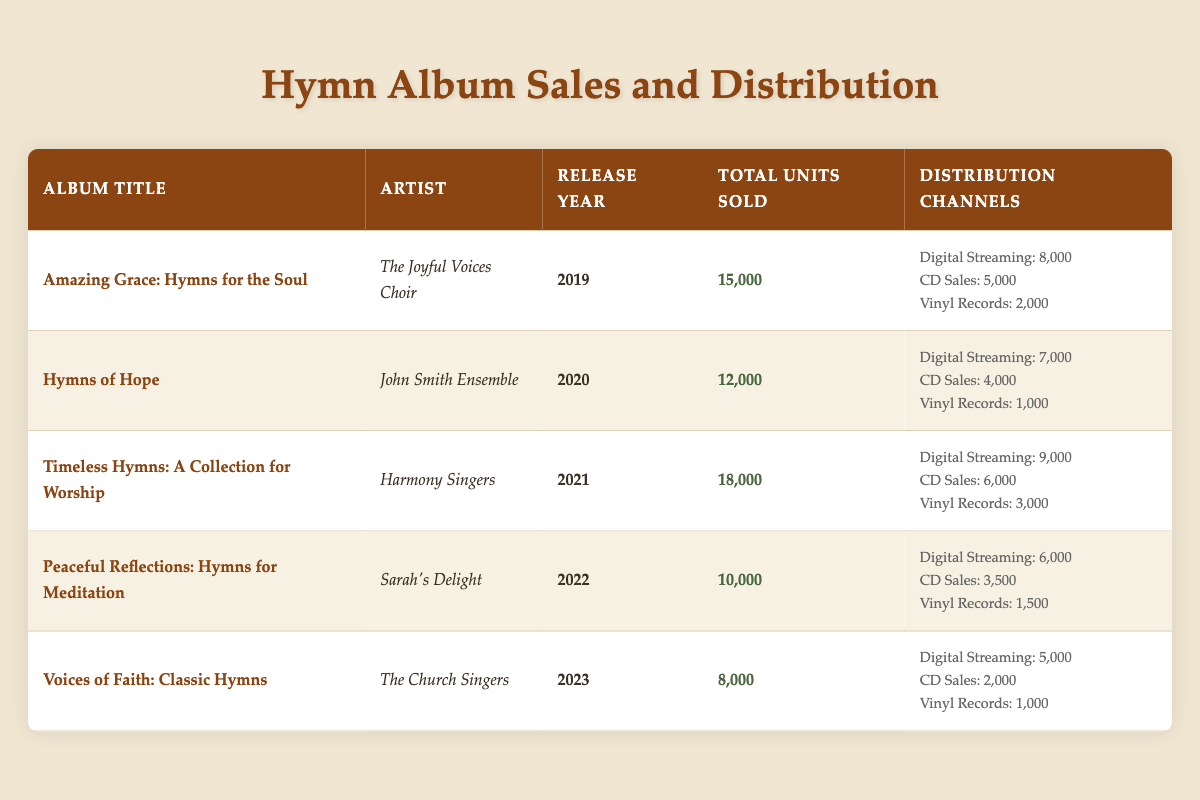What is the total number of units sold for "Timeless Hymns: A Collection for Worship"? The table lists the total units sold for each album. Referring to the row for "Timeless Hymns: A Collection for Worship," it shows 18,000 units sold.
Answer: 18,000 Which artist performed the album released in 2021? Looking at the release year column, the album released in 2021 is "Timeless Hymns: A Collection for Worship," and the corresponding artist is "Harmony Singers."
Answer: Harmony Singers What is the total number of units sold across all albums for the year 2020? The units sold for the album released in 2020, "Hymns of Hope," is 12,000. Since it's the only album from that year, no further calculations are needed.
Answer: 12,000 Which distribution channel sold the most units for "Amazing Grace: Hymns for the Soul"? The table shows the units sold by distribution channels for "Amazing Grace: Hymns for the Soul." Digital Streaming represents the highest sales with 8,000 units sold.
Answer: Digital Streaming Which album had the highest total sales over the five years? Examining the total units sold for each album, "Timeless Hymns: A Collection for Worship" has the highest total sales with 18,000 units. This album's total is greater than that of the other albums listed.
Answer: Timeless Hymns: A Collection for Worship Is the total number of units sold for "Peaceful Reflections: Hymns for Meditation" more than the average of the total units sold for all albums? First, we need to find the total units sold for all albums: 15,000 + 12,000 + 18,000 + 10,000 + 8,000 = 63,000. Then we calculate the average: 63,000 / 5 = 12,600. Now compare it with "Peaceful Reflections," which sold 10,000 units. 10,000 is less than 12,600, so the answer is no.
Answer: No What percentage of "Hymns of Hope" sales came from Digital Streaming? "Hymns of Hope" sold a total of 12,000 units, with 7,000 of those coming from Digital Streaming. To find the percentage, calculate (7,000 / 12,000) * 100, which is approximately 58.33%.
Answer: 58.33% How many more units were sold through CD Sales than Vinyl Records for "Voices of Faith: Classic Hymns"? "Voices of Faith" sold 2,000 units through CD Sales and 1,000 through Vinyl Records. The difference is 2,000 - 1,000 = 1,000.
Answer: 1,000 Did "The Joyful Voices Choir" have higher sales than "The Church Singers"? "The Joyful Voices Choir" sold 15,000 units for "Amazing Grace: Hymns for the Soul," while "The Church Singers" sold 8,000 for "Voices of Faith: Classic Hymns." Since 15,000 is greater than 8,000, the answer is yes.
Answer: Yes 